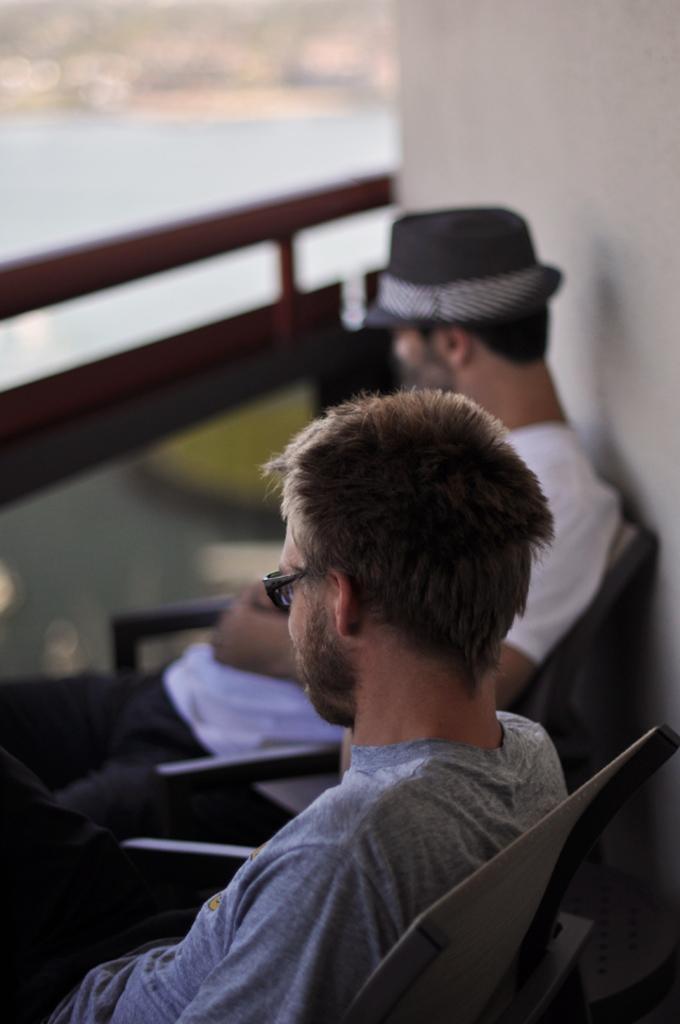How would you summarize this image in a sentence or two? In this image, we can see people sitting on the chairs and one of them is wearing glasses and the other is wearing a hat and in the background, we can see a wall and there is a railing. 